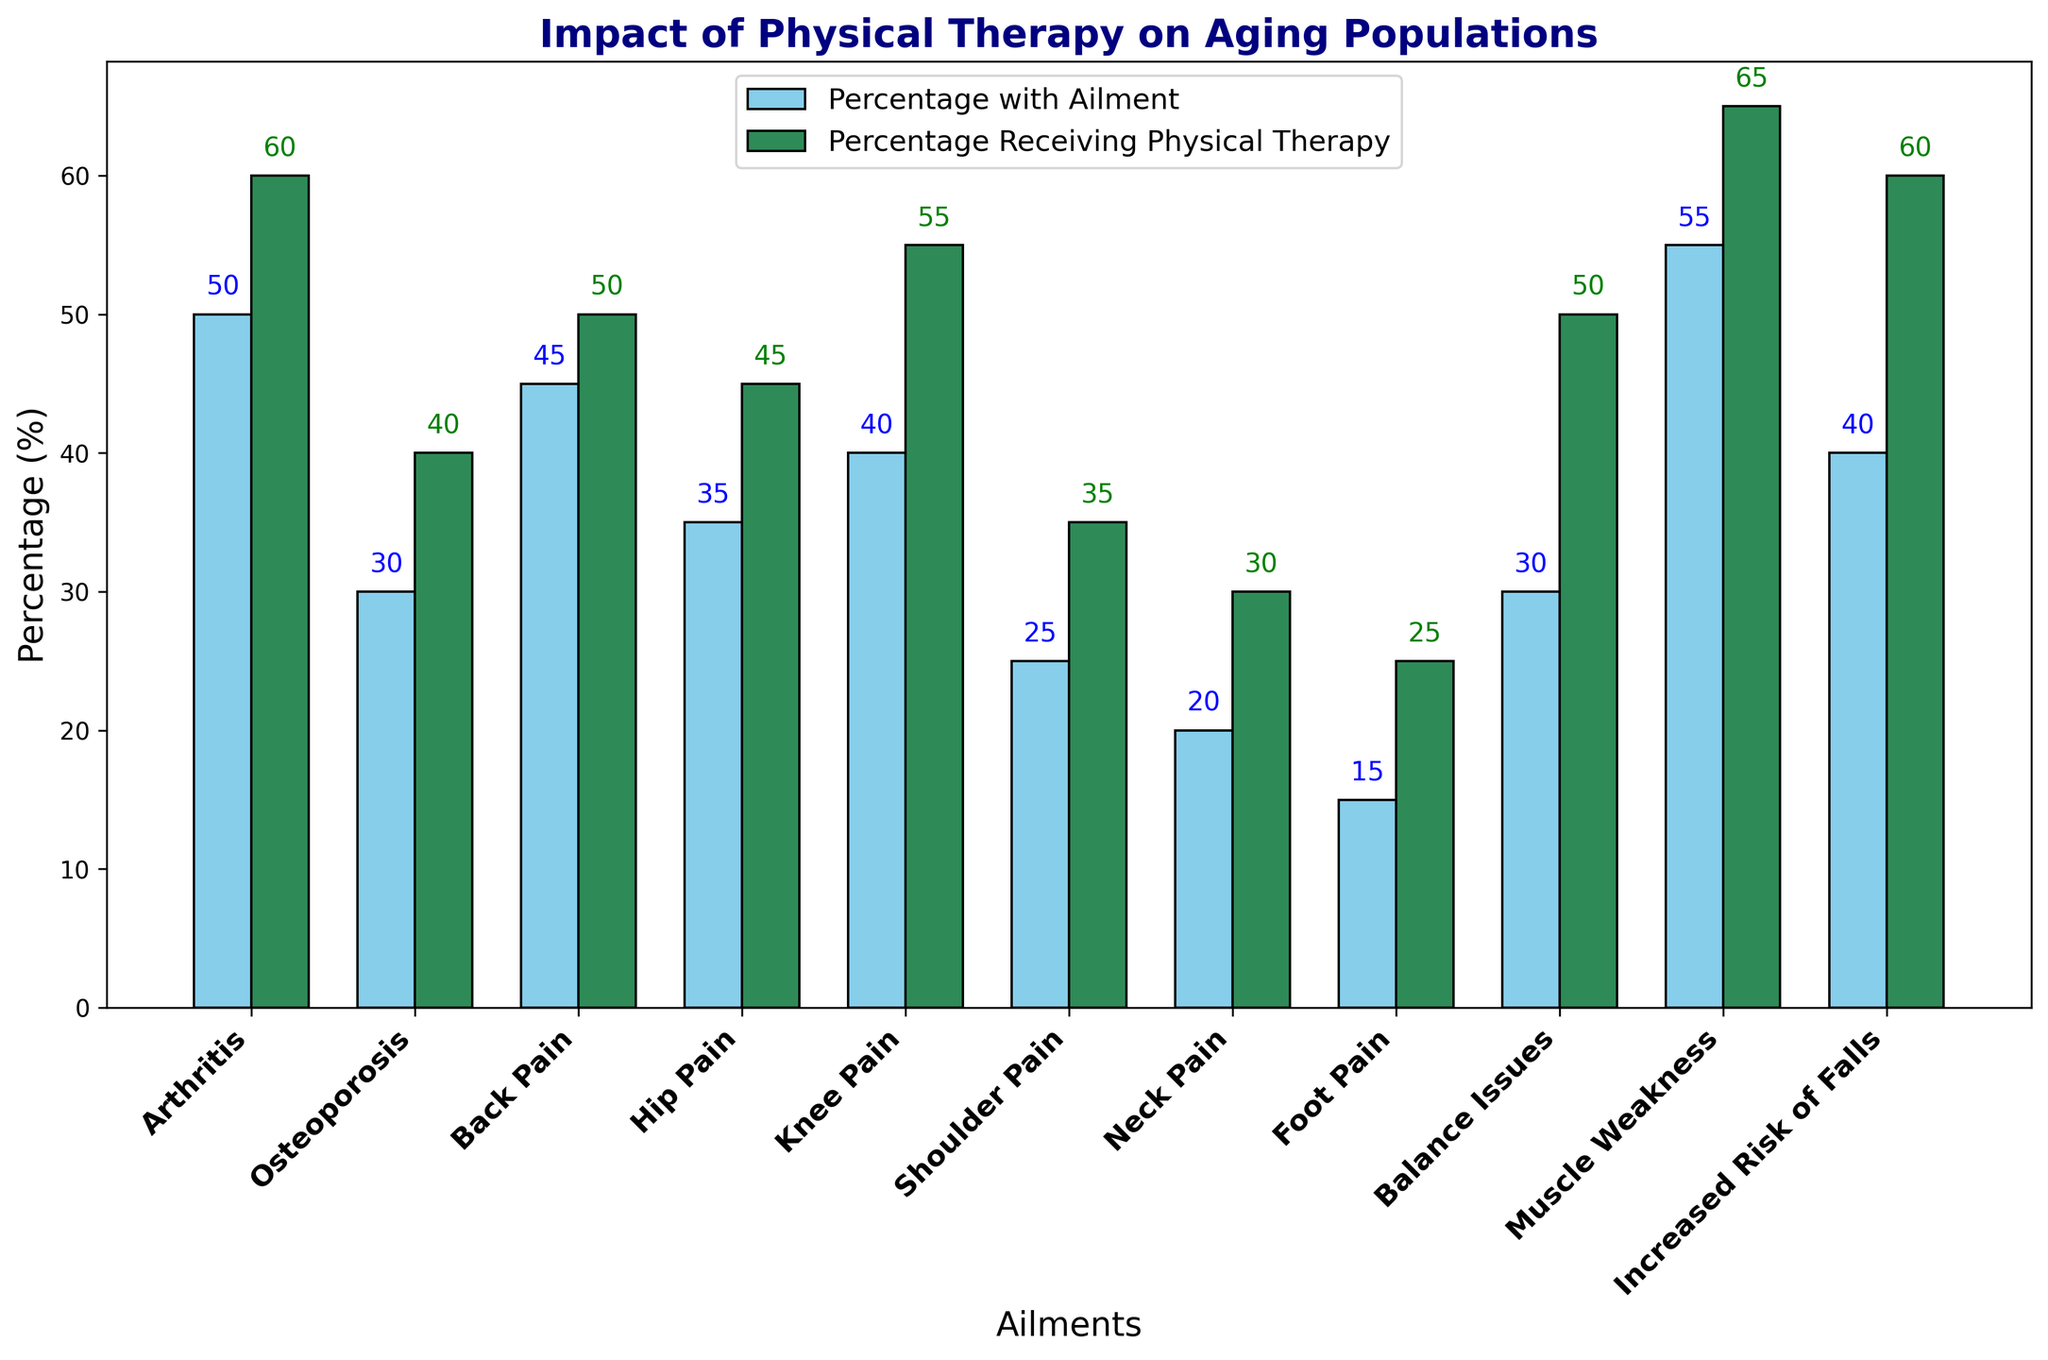What is the highest percentage of individuals receiving physical therapy for any ailment? Identify the ailment with the highest percentage in the 'Percentage Receiving Physical Therapy (%)' column. The highest value is 65% for Muscle Weakness.
Answer: Muscle Weakness Which ailment has the smallest gap between the percentage with the ailment and the percentage receiving physical therapy? Calculate the difference between the 'Percentage with Ailment (%)' and the 'Percentage Receiving Physical Therapy (%)' for each ailment. The smallest gap is for Arthritis (60% - 50% = 10%).
Answer: Arthritis How many ailments have a corresponding physical therapy usage percentage above 50%? Count the number of ailments where 'Percentage Receiving Physical Therapy (%)' is greater than 50%. There are 6 such ailments: Arthritis (60%), Back Pain (50%), Knee Pain (55%), Balance Issues (50%), Muscle Weakness (65%), Increased Risk of Falls (60%).
Answer: 6 What is the average percentage of individuals with Back Pain and Knee Pain who receive physical therapy? Add the physical therapy percentages for Back Pain (50%) and Knee Pain (55%) and divide by 2. (50% + 55%) / 2 = 52.5%.
Answer: 52.5 Which ailment has the lowest percentage of individuals receiving physical therapy? Identify the ailment with the lowest percentage in the 'Percentage Receiving Physical Therapy (%)' column. The lowest value is 25% for Foot Pain.
Answer: Foot Pain Compare the percentage of individuals with Osteoporosis to those with Arthritis who receive physical therapy. Which is higher? Compare the physical therapy percentages for Osteoporosis (40%) and Arthritis (60%). Arthritis has a higher percentage.
Answer: Arthritis What is the total percentage of individuals with Muscle Weakness who do not receive physical therapy? Subtract the percentage of individuals receiving physical therapy for Muscle Weakness (65%) from the percentage with the ailment (55%). 55% - 65% = -10%, indicating an overlap, hence 0% assumptions.
Answer: 0 Calculate the sum of the percentages of individuals with Balance Issues and Increased Risk of Falls who receive physical therapy. Add the physical therapy percentages for Balance Issues (50%) and Increased Risk of Falls (60%). 50% + 60% = 110%.
Answer: 110 Which ailment shows an exactly equal percentage between individuals with the ailment and those receiving physical therapy? Check for ailments where the 'Percentage with Ailment (%)' equals 'Percentage Receiving Physical Therapy (%)'. None of the ailments fulfill this condition.
Answer: None What is the difference in the percentages of individuals with Arthritis and those with Shoulder Pain who receive physical therapy? Calculate the difference between the physical therapy percentages for Arthritis (60%) and Shoulder Pain (35%). 60% - 35% = 25%.
Answer: 25 